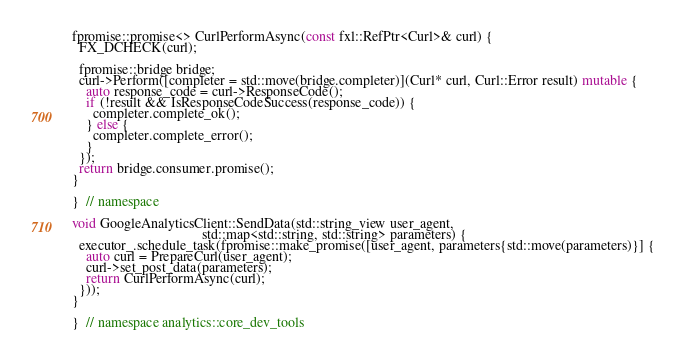<code> <loc_0><loc_0><loc_500><loc_500><_C++_>fpromise::promise<> CurlPerformAsync(const fxl::RefPtr<Curl>& curl) {
  FX_DCHECK(curl);

  fpromise::bridge bridge;
  curl->Perform([completer = std::move(bridge.completer)](Curl* curl, Curl::Error result) mutable {
    auto response_code = curl->ResponseCode();
    if (!result && IsResponseCodeSuccess(response_code)) {
      completer.complete_ok();
    } else {
      completer.complete_error();
    }
  });
  return bridge.consumer.promise();
}

}  // namespace

void GoogleAnalyticsClient::SendData(std::string_view user_agent,
                                     std::map<std::string, std::string> parameters) {
  executor_.schedule_task(fpromise::make_promise([user_agent, parameters{std::move(parameters)}] {
    auto curl = PrepareCurl(user_agent);
    curl->set_post_data(parameters);
    return CurlPerformAsync(curl);
  }));
}

}  // namespace analytics::core_dev_tools
</code> 